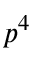<formula> <loc_0><loc_0><loc_500><loc_500>p ^ { 4 }</formula> 